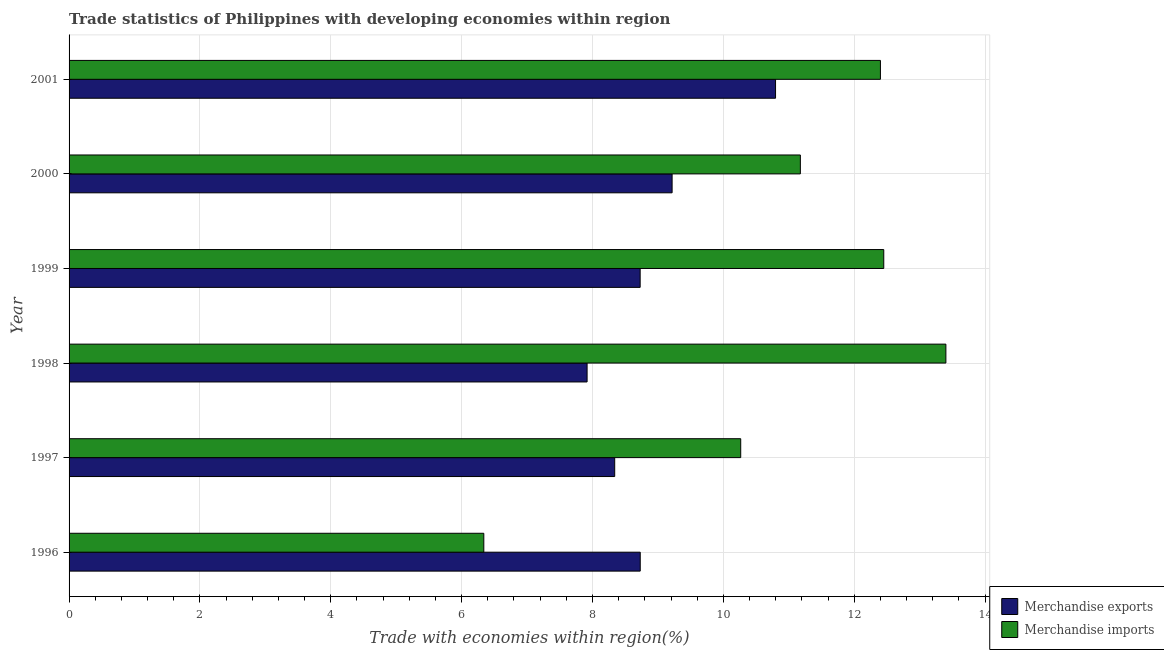How many different coloured bars are there?
Ensure brevity in your answer.  2. How many bars are there on the 6th tick from the bottom?
Ensure brevity in your answer.  2. In how many cases, is the number of bars for a given year not equal to the number of legend labels?
Provide a short and direct response. 0. What is the merchandise imports in 2000?
Offer a very short reply. 11.18. Across all years, what is the maximum merchandise exports?
Your response must be concise. 10.8. Across all years, what is the minimum merchandise imports?
Your response must be concise. 6.34. In which year was the merchandise imports minimum?
Offer a terse response. 1996. What is the total merchandise imports in the graph?
Make the answer very short. 66.04. What is the difference between the merchandise imports in 1996 and that in 1997?
Ensure brevity in your answer.  -3.93. What is the difference between the merchandise imports in 2001 and the merchandise exports in 1997?
Provide a succinct answer. 4.06. What is the average merchandise imports per year?
Ensure brevity in your answer.  11.01. In the year 1998, what is the difference between the merchandise exports and merchandise imports?
Provide a succinct answer. -5.48. What is the ratio of the merchandise imports in 1996 to that in 1997?
Your response must be concise. 0.62. Is the difference between the merchandise exports in 1996 and 1998 greater than the difference between the merchandise imports in 1996 and 1998?
Make the answer very short. Yes. What is the difference between the highest and the second highest merchandise imports?
Provide a short and direct response. 0.95. What is the difference between the highest and the lowest merchandise exports?
Offer a very short reply. 2.88. In how many years, is the merchandise imports greater than the average merchandise imports taken over all years?
Your answer should be very brief. 4. Is the sum of the merchandise imports in 1996 and 1998 greater than the maximum merchandise exports across all years?
Provide a succinct answer. Yes. What does the 1st bar from the top in 1998 represents?
Offer a terse response. Merchandise imports. What does the 2nd bar from the bottom in 1996 represents?
Keep it short and to the point. Merchandise imports. What is the difference between two consecutive major ticks on the X-axis?
Your answer should be very brief. 2. Are the values on the major ticks of X-axis written in scientific E-notation?
Ensure brevity in your answer.  No. Does the graph contain any zero values?
Offer a terse response. No. Does the graph contain grids?
Give a very brief answer. Yes. Where does the legend appear in the graph?
Keep it short and to the point. Bottom right. How many legend labels are there?
Provide a short and direct response. 2. How are the legend labels stacked?
Ensure brevity in your answer.  Vertical. What is the title of the graph?
Offer a terse response. Trade statistics of Philippines with developing economies within region. Does "Registered firms" appear as one of the legend labels in the graph?
Give a very brief answer. No. What is the label or title of the X-axis?
Provide a short and direct response. Trade with economies within region(%). What is the Trade with economies within region(%) of Merchandise exports in 1996?
Your response must be concise. 8.73. What is the Trade with economies within region(%) in Merchandise imports in 1996?
Provide a succinct answer. 6.34. What is the Trade with economies within region(%) of Merchandise exports in 1997?
Provide a short and direct response. 8.34. What is the Trade with economies within region(%) in Merchandise imports in 1997?
Give a very brief answer. 10.27. What is the Trade with economies within region(%) in Merchandise exports in 1998?
Provide a short and direct response. 7.92. What is the Trade with economies within region(%) in Merchandise imports in 1998?
Provide a short and direct response. 13.4. What is the Trade with economies within region(%) of Merchandise exports in 1999?
Provide a succinct answer. 8.73. What is the Trade with economies within region(%) in Merchandise imports in 1999?
Offer a very short reply. 12.45. What is the Trade with economies within region(%) of Merchandise exports in 2000?
Ensure brevity in your answer.  9.22. What is the Trade with economies within region(%) in Merchandise imports in 2000?
Your answer should be compact. 11.18. What is the Trade with economies within region(%) of Merchandise exports in 2001?
Make the answer very short. 10.8. What is the Trade with economies within region(%) in Merchandise imports in 2001?
Offer a very short reply. 12.4. Across all years, what is the maximum Trade with economies within region(%) in Merchandise exports?
Offer a terse response. 10.8. Across all years, what is the maximum Trade with economies within region(%) of Merchandise imports?
Your answer should be very brief. 13.4. Across all years, what is the minimum Trade with economies within region(%) of Merchandise exports?
Ensure brevity in your answer.  7.92. Across all years, what is the minimum Trade with economies within region(%) of Merchandise imports?
Offer a very short reply. 6.34. What is the total Trade with economies within region(%) in Merchandise exports in the graph?
Offer a very short reply. 53.73. What is the total Trade with economies within region(%) in Merchandise imports in the graph?
Ensure brevity in your answer.  66.04. What is the difference between the Trade with economies within region(%) of Merchandise exports in 1996 and that in 1997?
Your response must be concise. 0.39. What is the difference between the Trade with economies within region(%) of Merchandise imports in 1996 and that in 1997?
Ensure brevity in your answer.  -3.93. What is the difference between the Trade with economies within region(%) of Merchandise exports in 1996 and that in 1998?
Provide a succinct answer. 0.81. What is the difference between the Trade with economies within region(%) of Merchandise imports in 1996 and that in 1998?
Offer a very short reply. -7.06. What is the difference between the Trade with economies within region(%) in Merchandise exports in 1996 and that in 1999?
Provide a succinct answer. 0. What is the difference between the Trade with economies within region(%) in Merchandise imports in 1996 and that in 1999?
Ensure brevity in your answer.  -6.11. What is the difference between the Trade with economies within region(%) of Merchandise exports in 1996 and that in 2000?
Your answer should be compact. -0.49. What is the difference between the Trade with economies within region(%) of Merchandise imports in 1996 and that in 2000?
Give a very brief answer. -4.84. What is the difference between the Trade with economies within region(%) of Merchandise exports in 1996 and that in 2001?
Your response must be concise. -2.07. What is the difference between the Trade with economies within region(%) in Merchandise imports in 1996 and that in 2001?
Your response must be concise. -6.06. What is the difference between the Trade with economies within region(%) in Merchandise exports in 1997 and that in 1998?
Keep it short and to the point. 0.42. What is the difference between the Trade with economies within region(%) of Merchandise imports in 1997 and that in 1998?
Provide a succinct answer. -3.14. What is the difference between the Trade with economies within region(%) in Merchandise exports in 1997 and that in 1999?
Offer a very short reply. -0.39. What is the difference between the Trade with economies within region(%) in Merchandise imports in 1997 and that in 1999?
Your answer should be very brief. -2.19. What is the difference between the Trade with economies within region(%) of Merchandise exports in 1997 and that in 2000?
Give a very brief answer. -0.88. What is the difference between the Trade with economies within region(%) in Merchandise imports in 1997 and that in 2000?
Provide a succinct answer. -0.91. What is the difference between the Trade with economies within region(%) of Merchandise exports in 1997 and that in 2001?
Offer a terse response. -2.46. What is the difference between the Trade with economies within region(%) of Merchandise imports in 1997 and that in 2001?
Provide a short and direct response. -2.14. What is the difference between the Trade with economies within region(%) of Merchandise exports in 1998 and that in 1999?
Give a very brief answer. -0.81. What is the difference between the Trade with economies within region(%) of Merchandise imports in 1998 and that in 1999?
Ensure brevity in your answer.  0.95. What is the difference between the Trade with economies within region(%) in Merchandise exports in 1998 and that in 2000?
Give a very brief answer. -1.3. What is the difference between the Trade with economies within region(%) in Merchandise imports in 1998 and that in 2000?
Your answer should be compact. 2.22. What is the difference between the Trade with economies within region(%) in Merchandise exports in 1998 and that in 2001?
Offer a very short reply. -2.88. What is the difference between the Trade with economies within region(%) in Merchandise exports in 1999 and that in 2000?
Provide a short and direct response. -0.49. What is the difference between the Trade with economies within region(%) of Merchandise imports in 1999 and that in 2000?
Ensure brevity in your answer.  1.27. What is the difference between the Trade with economies within region(%) in Merchandise exports in 1999 and that in 2001?
Offer a terse response. -2.07. What is the difference between the Trade with economies within region(%) of Merchandise imports in 1999 and that in 2001?
Offer a terse response. 0.05. What is the difference between the Trade with economies within region(%) in Merchandise exports in 2000 and that in 2001?
Provide a succinct answer. -1.58. What is the difference between the Trade with economies within region(%) of Merchandise imports in 2000 and that in 2001?
Ensure brevity in your answer.  -1.22. What is the difference between the Trade with economies within region(%) of Merchandise exports in 1996 and the Trade with economies within region(%) of Merchandise imports in 1997?
Provide a short and direct response. -1.54. What is the difference between the Trade with economies within region(%) of Merchandise exports in 1996 and the Trade with economies within region(%) of Merchandise imports in 1998?
Offer a terse response. -4.67. What is the difference between the Trade with economies within region(%) in Merchandise exports in 1996 and the Trade with economies within region(%) in Merchandise imports in 1999?
Offer a very short reply. -3.72. What is the difference between the Trade with economies within region(%) in Merchandise exports in 1996 and the Trade with economies within region(%) in Merchandise imports in 2000?
Offer a terse response. -2.45. What is the difference between the Trade with economies within region(%) of Merchandise exports in 1996 and the Trade with economies within region(%) of Merchandise imports in 2001?
Provide a succinct answer. -3.67. What is the difference between the Trade with economies within region(%) of Merchandise exports in 1997 and the Trade with economies within region(%) of Merchandise imports in 1998?
Provide a succinct answer. -5.06. What is the difference between the Trade with economies within region(%) in Merchandise exports in 1997 and the Trade with economies within region(%) in Merchandise imports in 1999?
Your answer should be very brief. -4.11. What is the difference between the Trade with economies within region(%) in Merchandise exports in 1997 and the Trade with economies within region(%) in Merchandise imports in 2000?
Keep it short and to the point. -2.84. What is the difference between the Trade with economies within region(%) of Merchandise exports in 1997 and the Trade with economies within region(%) of Merchandise imports in 2001?
Provide a short and direct response. -4.06. What is the difference between the Trade with economies within region(%) of Merchandise exports in 1998 and the Trade with economies within region(%) of Merchandise imports in 1999?
Provide a short and direct response. -4.53. What is the difference between the Trade with economies within region(%) in Merchandise exports in 1998 and the Trade with economies within region(%) in Merchandise imports in 2000?
Offer a very short reply. -3.26. What is the difference between the Trade with economies within region(%) in Merchandise exports in 1998 and the Trade with economies within region(%) in Merchandise imports in 2001?
Your response must be concise. -4.48. What is the difference between the Trade with economies within region(%) in Merchandise exports in 1999 and the Trade with economies within region(%) in Merchandise imports in 2000?
Keep it short and to the point. -2.45. What is the difference between the Trade with economies within region(%) of Merchandise exports in 1999 and the Trade with economies within region(%) of Merchandise imports in 2001?
Provide a short and direct response. -3.67. What is the difference between the Trade with economies within region(%) of Merchandise exports in 2000 and the Trade with economies within region(%) of Merchandise imports in 2001?
Your response must be concise. -3.18. What is the average Trade with economies within region(%) of Merchandise exports per year?
Your answer should be very brief. 8.96. What is the average Trade with economies within region(%) of Merchandise imports per year?
Provide a succinct answer. 11.01. In the year 1996, what is the difference between the Trade with economies within region(%) in Merchandise exports and Trade with economies within region(%) in Merchandise imports?
Ensure brevity in your answer.  2.39. In the year 1997, what is the difference between the Trade with economies within region(%) in Merchandise exports and Trade with economies within region(%) in Merchandise imports?
Offer a terse response. -1.93. In the year 1998, what is the difference between the Trade with economies within region(%) in Merchandise exports and Trade with economies within region(%) in Merchandise imports?
Keep it short and to the point. -5.48. In the year 1999, what is the difference between the Trade with economies within region(%) of Merchandise exports and Trade with economies within region(%) of Merchandise imports?
Make the answer very short. -3.72. In the year 2000, what is the difference between the Trade with economies within region(%) of Merchandise exports and Trade with economies within region(%) of Merchandise imports?
Your answer should be compact. -1.96. In the year 2001, what is the difference between the Trade with economies within region(%) in Merchandise exports and Trade with economies within region(%) in Merchandise imports?
Make the answer very short. -1.6. What is the ratio of the Trade with economies within region(%) of Merchandise exports in 1996 to that in 1997?
Provide a short and direct response. 1.05. What is the ratio of the Trade with economies within region(%) in Merchandise imports in 1996 to that in 1997?
Your answer should be compact. 0.62. What is the ratio of the Trade with economies within region(%) in Merchandise exports in 1996 to that in 1998?
Make the answer very short. 1.1. What is the ratio of the Trade with economies within region(%) of Merchandise imports in 1996 to that in 1998?
Provide a succinct answer. 0.47. What is the ratio of the Trade with economies within region(%) in Merchandise imports in 1996 to that in 1999?
Offer a very short reply. 0.51. What is the ratio of the Trade with economies within region(%) of Merchandise exports in 1996 to that in 2000?
Offer a terse response. 0.95. What is the ratio of the Trade with economies within region(%) of Merchandise imports in 1996 to that in 2000?
Your answer should be compact. 0.57. What is the ratio of the Trade with economies within region(%) in Merchandise exports in 1996 to that in 2001?
Provide a short and direct response. 0.81. What is the ratio of the Trade with economies within region(%) in Merchandise imports in 1996 to that in 2001?
Give a very brief answer. 0.51. What is the ratio of the Trade with economies within region(%) of Merchandise exports in 1997 to that in 1998?
Make the answer very short. 1.05. What is the ratio of the Trade with economies within region(%) of Merchandise imports in 1997 to that in 1998?
Offer a very short reply. 0.77. What is the ratio of the Trade with economies within region(%) in Merchandise exports in 1997 to that in 1999?
Your answer should be very brief. 0.96. What is the ratio of the Trade with economies within region(%) in Merchandise imports in 1997 to that in 1999?
Ensure brevity in your answer.  0.82. What is the ratio of the Trade with economies within region(%) of Merchandise exports in 1997 to that in 2000?
Your response must be concise. 0.9. What is the ratio of the Trade with economies within region(%) of Merchandise imports in 1997 to that in 2000?
Your response must be concise. 0.92. What is the ratio of the Trade with economies within region(%) of Merchandise exports in 1997 to that in 2001?
Your answer should be very brief. 0.77. What is the ratio of the Trade with economies within region(%) in Merchandise imports in 1997 to that in 2001?
Offer a very short reply. 0.83. What is the ratio of the Trade with economies within region(%) in Merchandise exports in 1998 to that in 1999?
Keep it short and to the point. 0.91. What is the ratio of the Trade with economies within region(%) in Merchandise imports in 1998 to that in 1999?
Offer a terse response. 1.08. What is the ratio of the Trade with economies within region(%) in Merchandise exports in 1998 to that in 2000?
Ensure brevity in your answer.  0.86. What is the ratio of the Trade with economies within region(%) of Merchandise imports in 1998 to that in 2000?
Ensure brevity in your answer.  1.2. What is the ratio of the Trade with economies within region(%) of Merchandise exports in 1998 to that in 2001?
Make the answer very short. 0.73. What is the ratio of the Trade with economies within region(%) of Merchandise imports in 1998 to that in 2001?
Your answer should be compact. 1.08. What is the ratio of the Trade with economies within region(%) of Merchandise exports in 1999 to that in 2000?
Keep it short and to the point. 0.95. What is the ratio of the Trade with economies within region(%) of Merchandise imports in 1999 to that in 2000?
Ensure brevity in your answer.  1.11. What is the ratio of the Trade with economies within region(%) in Merchandise exports in 1999 to that in 2001?
Your answer should be compact. 0.81. What is the ratio of the Trade with economies within region(%) of Merchandise exports in 2000 to that in 2001?
Provide a short and direct response. 0.85. What is the ratio of the Trade with economies within region(%) in Merchandise imports in 2000 to that in 2001?
Your answer should be very brief. 0.9. What is the difference between the highest and the second highest Trade with economies within region(%) of Merchandise exports?
Provide a succinct answer. 1.58. What is the difference between the highest and the second highest Trade with economies within region(%) in Merchandise imports?
Give a very brief answer. 0.95. What is the difference between the highest and the lowest Trade with economies within region(%) of Merchandise exports?
Ensure brevity in your answer.  2.88. What is the difference between the highest and the lowest Trade with economies within region(%) of Merchandise imports?
Give a very brief answer. 7.06. 